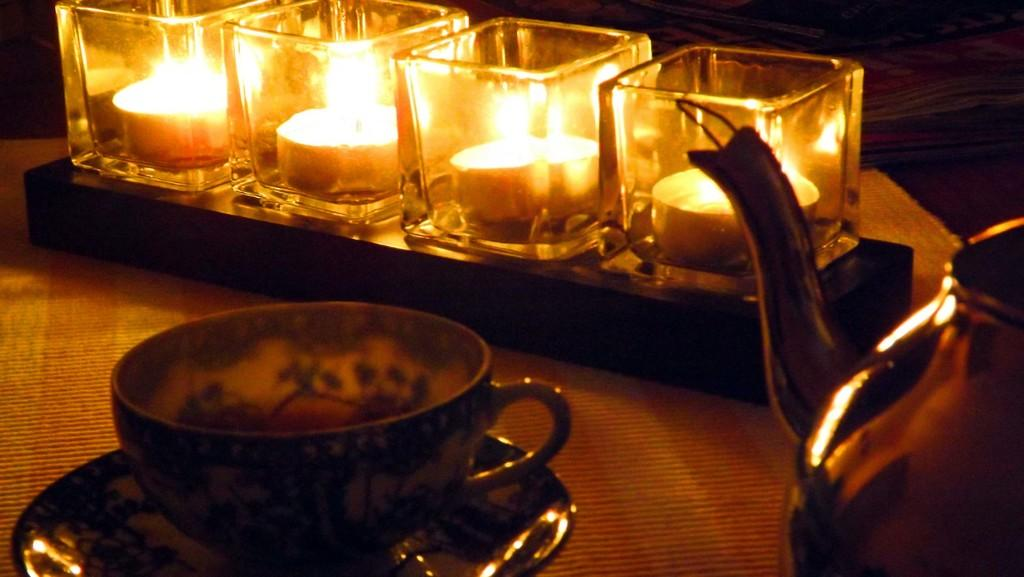What type of furniture is present in the image? There is a table in the image. What items are placed on the table? There is a cup and saucer, candles in glasses, and a kettle on the table. What type of fuel is used to power the candles in the image? There are no candles in the image that require fuel; they are likely powered by wax. 